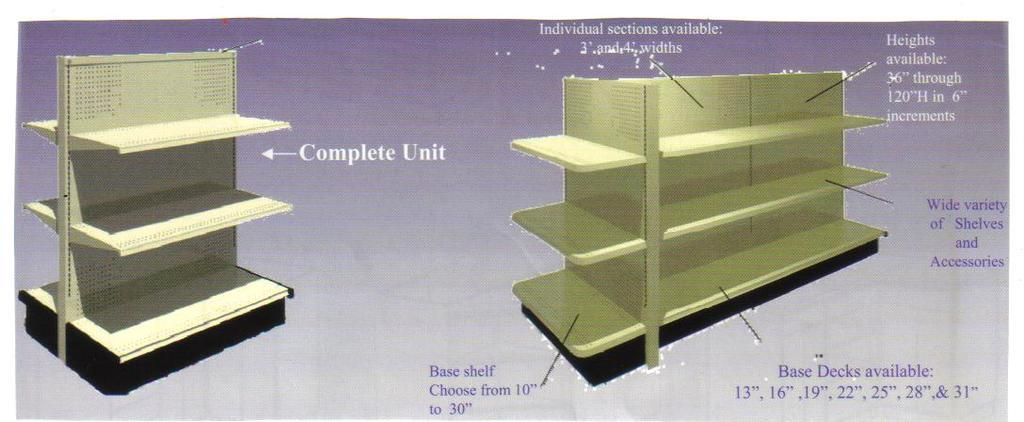<image>
Relay a brief, clear account of the picture shown. A diagram shows what the complete unit of a shelving unit looks like. 